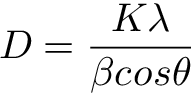<formula> <loc_0><loc_0><loc_500><loc_500>D = \frac { K \lambda } { \beta \cos \theta }</formula> 